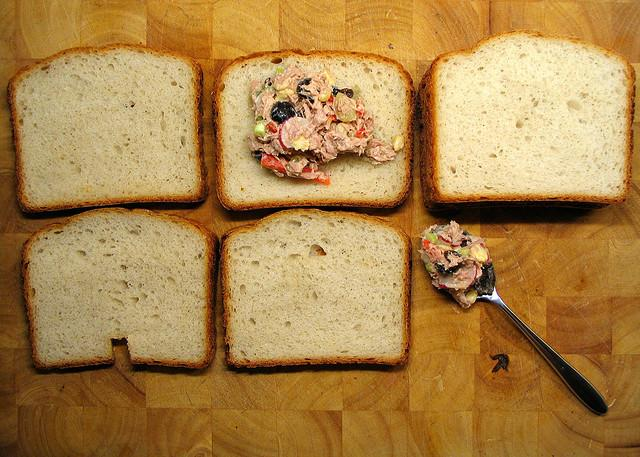How many slices of bread will filling be put on? three 